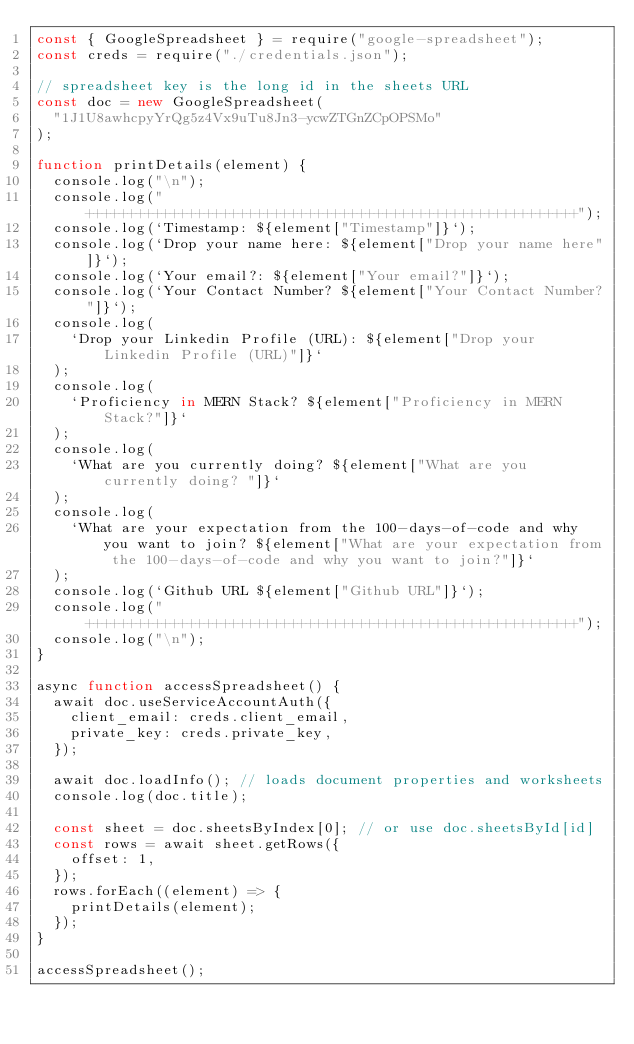<code> <loc_0><loc_0><loc_500><loc_500><_JavaScript_>const { GoogleSpreadsheet } = require("google-spreadsheet");
const creds = require("./credentials.json");

// spreadsheet key is the long id in the sheets URL
const doc = new GoogleSpreadsheet(
  "1J1U8awhcpyYrQg5z4Vx9uTu8Jn3-ycwZTGnZCpOPSMo"
);

function printDetails(element) {
  console.log("\n");
  console.log("++++++++++++++++++++++++++++++++++++++++++++++++++++++++++");
  console.log(`Timestamp: ${element["Timestamp"]}`);
  console.log(`Drop your name here: ${element["Drop your name here"]}`);
  console.log(`Your email?: ${element["Your email?"]}`);
  console.log(`Your Contact Number? ${element["Your Contact Number?"]}`);
  console.log(
    `Drop your Linkedin Profile (URL): ${element["Drop your Linkedin Profile (URL)"]}`
  );
  console.log(
    `Proficiency in MERN Stack? ${element["Proficiency in MERN Stack?"]}`
  );
  console.log(
    `What are you currently doing? ${element["What are you currently doing? "]}`
  );
  console.log(
    `What are your expectation from the 100-days-of-code and why you want to join? ${element["What are your expectation from the 100-days-of-code and why you want to join?"]}`
  );
  console.log(`Github URL ${element["Github URL"]}`);
  console.log("++++++++++++++++++++++++++++++++++++++++++++++++++++++++++");
  console.log("\n");
}

async function accessSpreadsheet() {
  await doc.useServiceAccountAuth({
    client_email: creds.client_email,
    private_key: creds.private_key,
  });

  await doc.loadInfo(); // loads document properties and worksheets
  console.log(doc.title);

  const sheet = doc.sheetsByIndex[0]; // or use doc.sheetsById[id]
  const rows = await sheet.getRows({
    offset: 1,
  });
  rows.forEach((element) => {
    printDetails(element);
  });
}

accessSpreadsheet();
</code> 